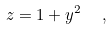Convert formula to latex. <formula><loc_0><loc_0><loc_500><loc_500>z = 1 + y ^ { 2 } \ \ ,</formula> 